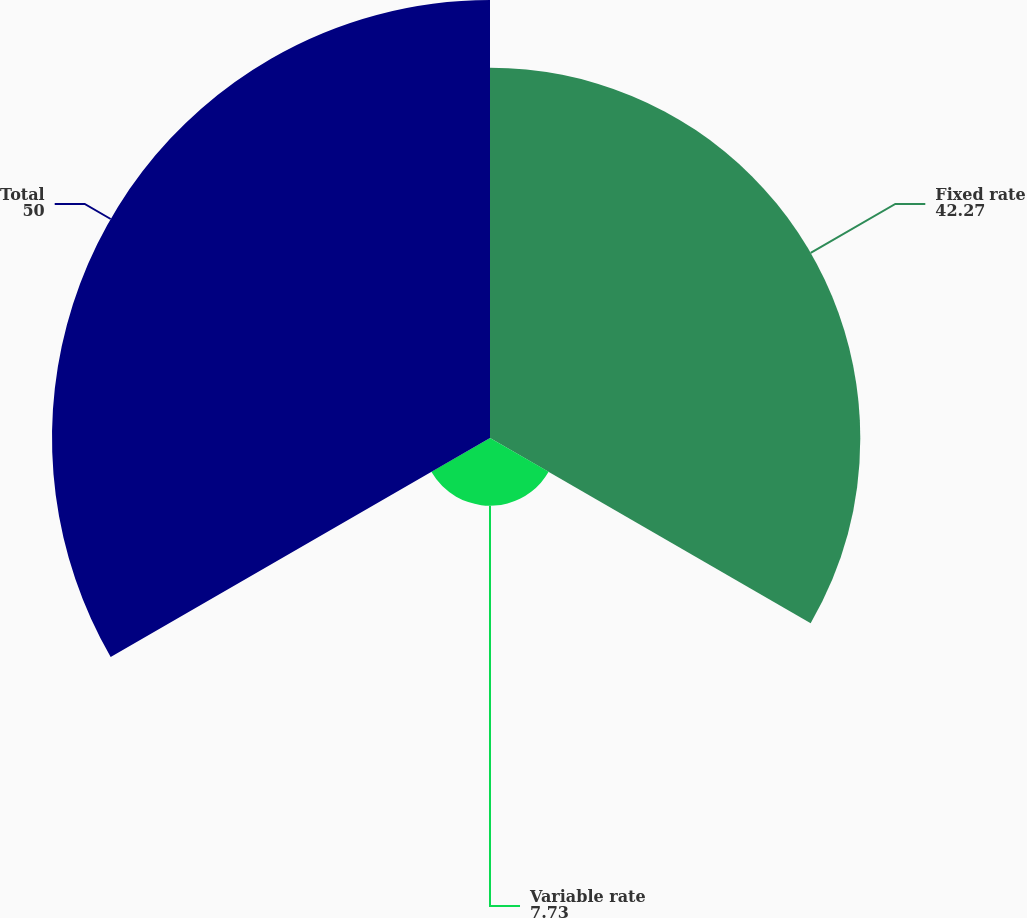Convert chart to OTSL. <chart><loc_0><loc_0><loc_500><loc_500><pie_chart><fcel>Fixed rate<fcel>Variable rate<fcel>Total<nl><fcel>42.27%<fcel>7.73%<fcel>50.0%<nl></chart> 